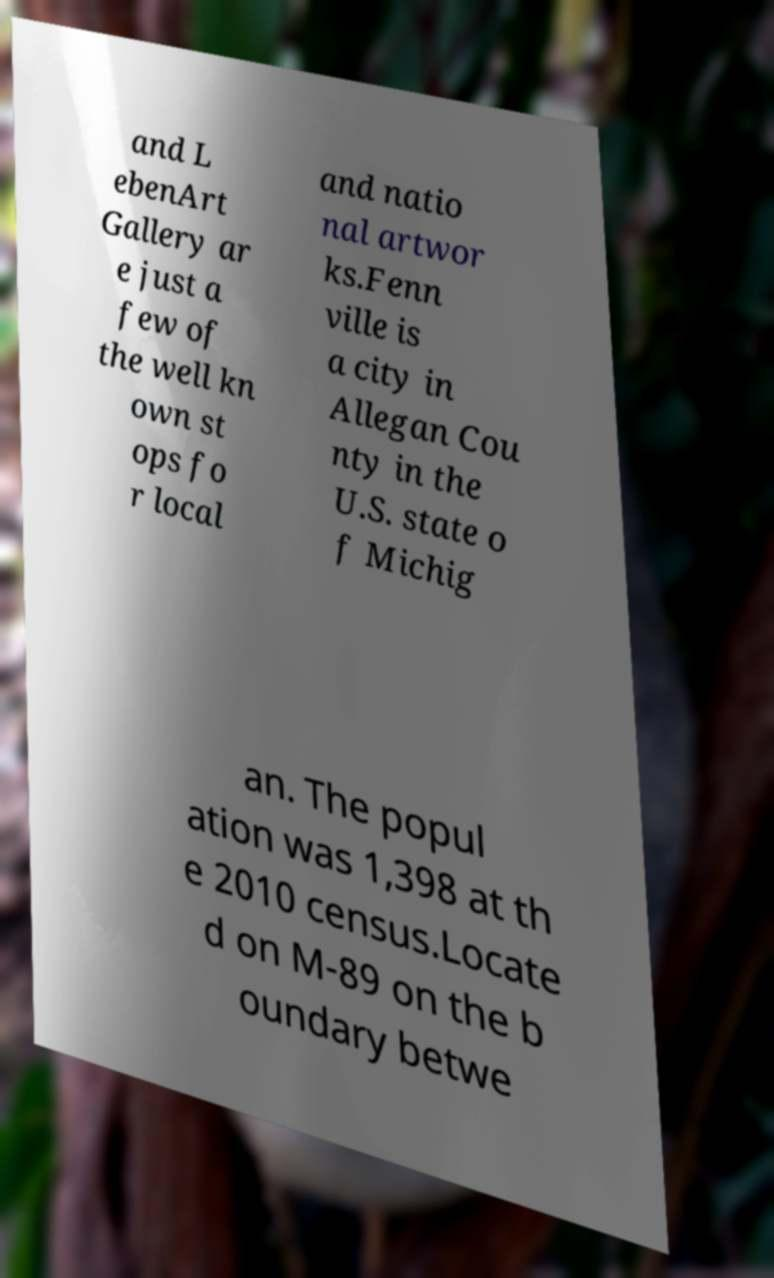I need the written content from this picture converted into text. Can you do that? and L ebenArt Gallery ar e just a few of the well kn own st ops fo r local and natio nal artwor ks.Fenn ville is a city in Allegan Cou nty in the U.S. state o f Michig an. The popul ation was 1,398 at th e 2010 census.Locate d on M-89 on the b oundary betwe 